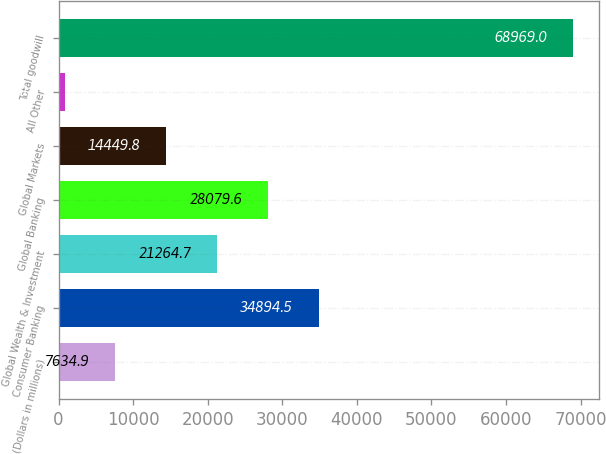<chart> <loc_0><loc_0><loc_500><loc_500><bar_chart><fcel>(Dollars in millions)<fcel>Consumer Banking<fcel>Global Wealth & Investment<fcel>Global Banking<fcel>Global Markets<fcel>All Other<fcel>Total goodwill<nl><fcel>7634.9<fcel>34894.5<fcel>21264.7<fcel>28079.6<fcel>14449.8<fcel>820<fcel>68969<nl></chart> 